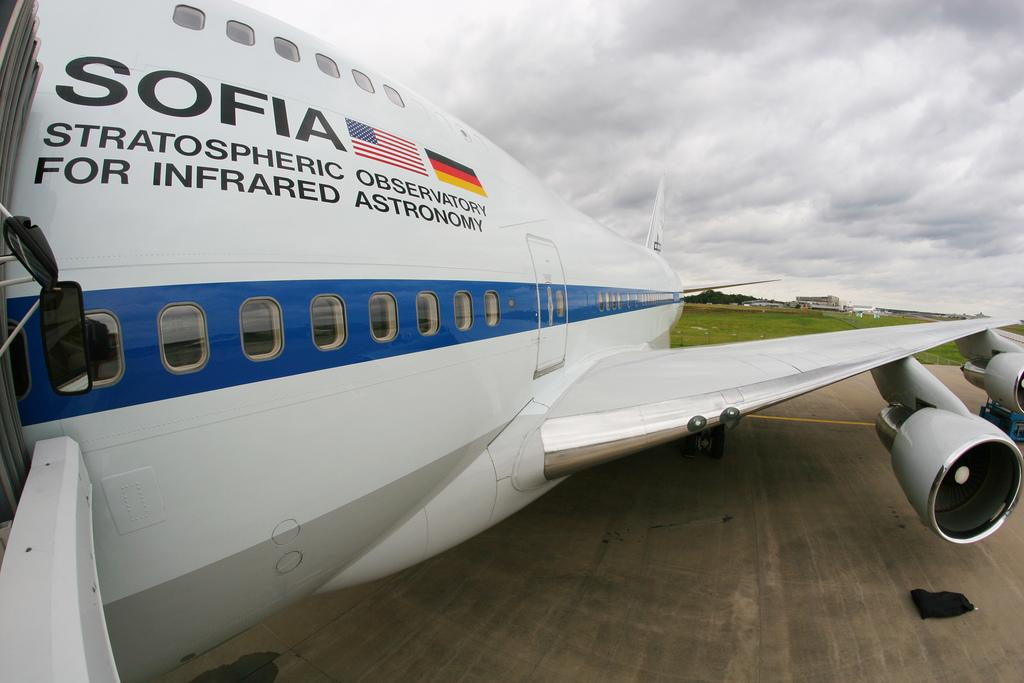<image>
Summarize the visual content of the image. A close up of SOPHIA, a high altitude plane at the terminal. 